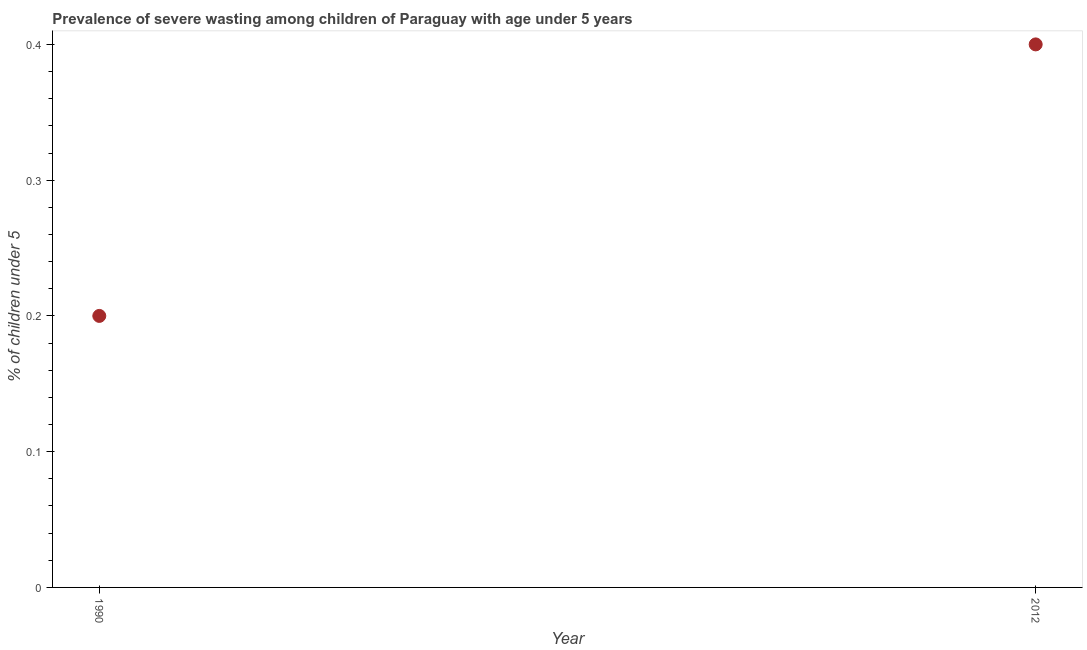What is the prevalence of severe wasting in 1990?
Ensure brevity in your answer.  0.2. Across all years, what is the maximum prevalence of severe wasting?
Your response must be concise. 0.4. Across all years, what is the minimum prevalence of severe wasting?
Offer a very short reply. 0.2. In which year was the prevalence of severe wasting maximum?
Your answer should be compact. 2012. What is the sum of the prevalence of severe wasting?
Provide a succinct answer. 0.6. What is the difference between the prevalence of severe wasting in 1990 and 2012?
Provide a succinct answer. -0.2. What is the average prevalence of severe wasting per year?
Provide a short and direct response. 0.3. What is the median prevalence of severe wasting?
Your answer should be compact. 0.3. In how many years, is the prevalence of severe wasting greater than 0.08 %?
Provide a short and direct response. 2. Do a majority of the years between 1990 and 2012 (inclusive) have prevalence of severe wasting greater than 0.1 %?
Offer a terse response. Yes. How many dotlines are there?
Your answer should be very brief. 1. How many years are there in the graph?
Keep it short and to the point. 2. Are the values on the major ticks of Y-axis written in scientific E-notation?
Your answer should be compact. No. Does the graph contain any zero values?
Give a very brief answer. No. Does the graph contain grids?
Your answer should be compact. No. What is the title of the graph?
Make the answer very short. Prevalence of severe wasting among children of Paraguay with age under 5 years. What is the label or title of the X-axis?
Provide a succinct answer. Year. What is the label or title of the Y-axis?
Your response must be concise.  % of children under 5. What is the  % of children under 5 in 1990?
Offer a very short reply. 0.2. What is the  % of children under 5 in 2012?
Offer a terse response. 0.4. What is the difference between the  % of children under 5 in 1990 and 2012?
Provide a short and direct response. -0.2. 